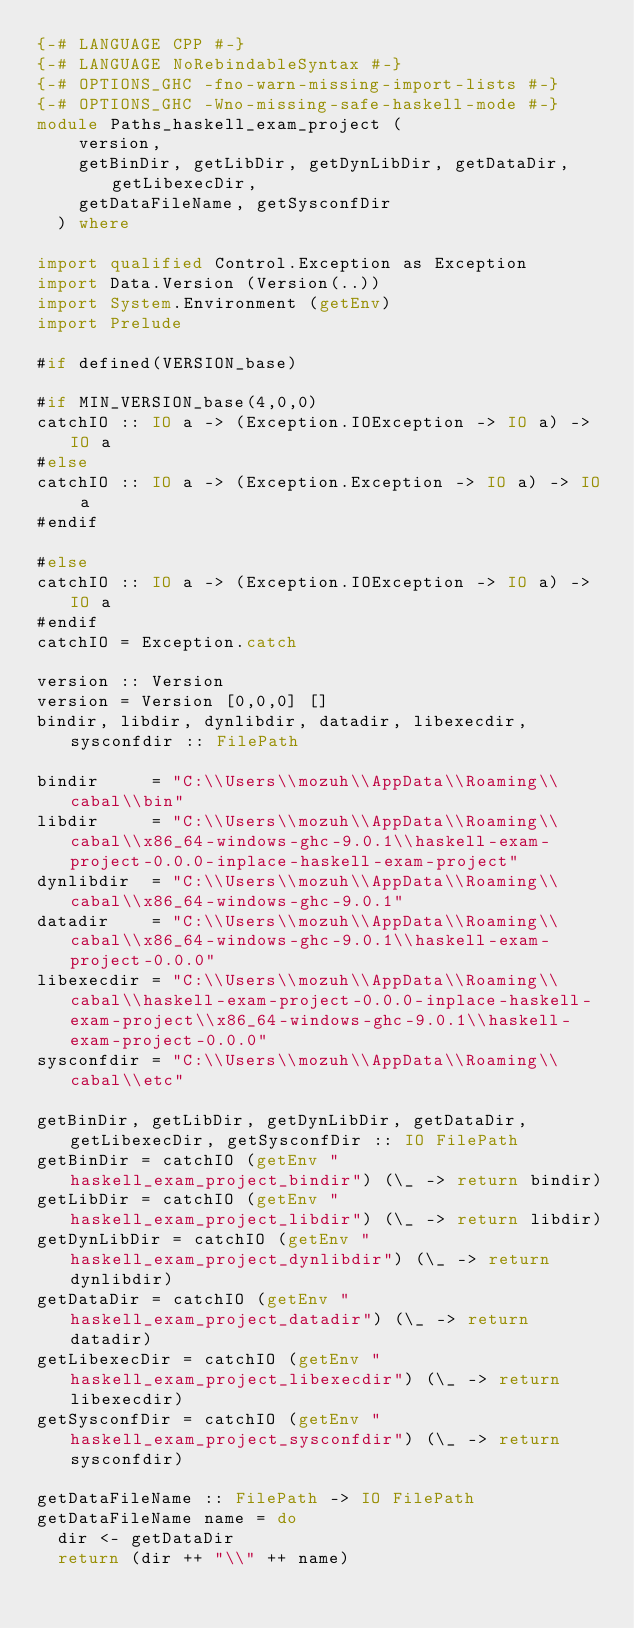<code> <loc_0><loc_0><loc_500><loc_500><_Haskell_>{-# LANGUAGE CPP #-}
{-# LANGUAGE NoRebindableSyntax #-}
{-# OPTIONS_GHC -fno-warn-missing-import-lists #-}
{-# OPTIONS_GHC -Wno-missing-safe-haskell-mode #-}
module Paths_haskell_exam_project (
    version,
    getBinDir, getLibDir, getDynLibDir, getDataDir, getLibexecDir,
    getDataFileName, getSysconfDir
  ) where

import qualified Control.Exception as Exception
import Data.Version (Version(..))
import System.Environment (getEnv)
import Prelude

#if defined(VERSION_base)

#if MIN_VERSION_base(4,0,0)
catchIO :: IO a -> (Exception.IOException -> IO a) -> IO a
#else
catchIO :: IO a -> (Exception.Exception -> IO a) -> IO a
#endif

#else
catchIO :: IO a -> (Exception.IOException -> IO a) -> IO a
#endif
catchIO = Exception.catch

version :: Version
version = Version [0,0,0] []
bindir, libdir, dynlibdir, datadir, libexecdir, sysconfdir :: FilePath

bindir     = "C:\\Users\\mozuh\\AppData\\Roaming\\cabal\\bin"
libdir     = "C:\\Users\\mozuh\\AppData\\Roaming\\cabal\\x86_64-windows-ghc-9.0.1\\haskell-exam-project-0.0.0-inplace-haskell-exam-project"
dynlibdir  = "C:\\Users\\mozuh\\AppData\\Roaming\\cabal\\x86_64-windows-ghc-9.0.1"
datadir    = "C:\\Users\\mozuh\\AppData\\Roaming\\cabal\\x86_64-windows-ghc-9.0.1\\haskell-exam-project-0.0.0"
libexecdir = "C:\\Users\\mozuh\\AppData\\Roaming\\cabal\\haskell-exam-project-0.0.0-inplace-haskell-exam-project\\x86_64-windows-ghc-9.0.1\\haskell-exam-project-0.0.0"
sysconfdir = "C:\\Users\\mozuh\\AppData\\Roaming\\cabal\\etc"

getBinDir, getLibDir, getDynLibDir, getDataDir, getLibexecDir, getSysconfDir :: IO FilePath
getBinDir = catchIO (getEnv "haskell_exam_project_bindir") (\_ -> return bindir)
getLibDir = catchIO (getEnv "haskell_exam_project_libdir") (\_ -> return libdir)
getDynLibDir = catchIO (getEnv "haskell_exam_project_dynlibdir") (\_ -> return dynlibdir)
getDataDir = catchIO (getEnv "haskell_exam_project_datadir") (\_ -> return datadir)
getLibexecDir = catchIO (getEnv "haskell_exam_project_libexecdir") (\_ -> return libexecdir)
getSysconfDir = catchIO (getEnv "haskell_exam_project_sysconfdir") (\_ -> return sysconfdir)

getDataFileName :: FilePath -> IO FilePath
getDataFileName name = do
  dir <- getDataDir
  return (dir ++ "\\" ++ name)
</code> 